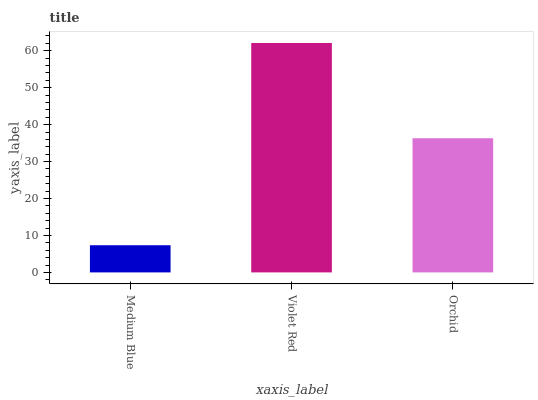Is Medium Blue the minimum?
Answer yes or no. Yes. Is Violet Red the maximum?
Answer yes or no. Yes. Is Orchid the minimum?
Answer yes or no. No. Is Orchid the maximum?
Answer yes or no. No. Is Violet Red greater than Orchid?
Answer yes or no. Yes. Is Orchid less than Violet Red?
Answer yes or no. Yes. Is Orchid greater than Violet Red?
Answer yes or no. No. Is Violet Red less than Orchid?
Answer yes or no. No. Is Orchid the high median?
Answer yes or no. Yes. Is Orchid the low median?
Answer yes or no. Yes. Is Violet Red the high median?
Answer yes or no. No. Is Medium Blue the low median?
Answer yes or no. No. 